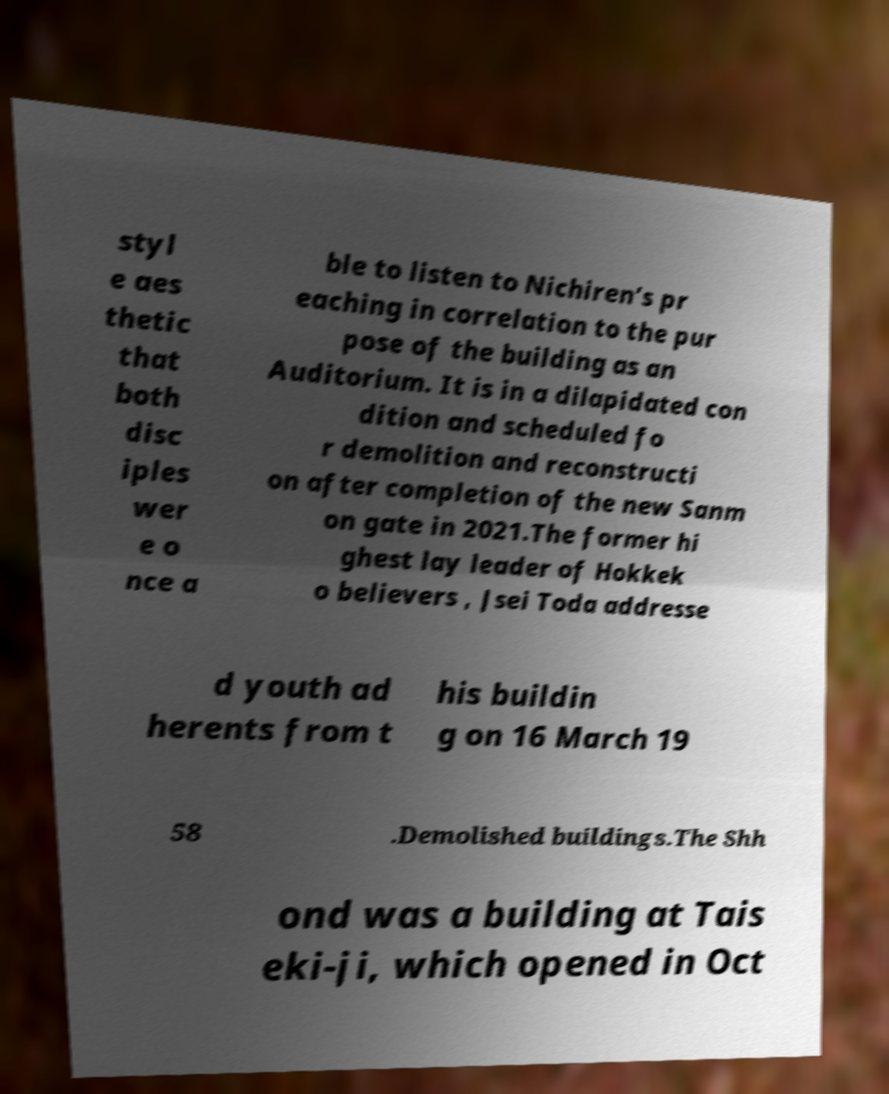For documentation purposes, I need the text within this image transcribed. Could you provide that? styl e aes thetic that both disc iples wer e o nce a ble to listen to Nichiren’s pr eaching in correlation to the pur pose of the building as an Auditorium. It is in a dilapidated con dition and scheduled fo r demolition and reconstructi on after completion of the new Sanm on gate in 2021.The former hi ghest lay leader of Hokkek o believers , Jsei Toda addresse d youth ad herents from t his buildin g on 16 March 19 58 .Demolished buildings.The Shh ond was a building at Tais eki-ji, which opened in Oct 